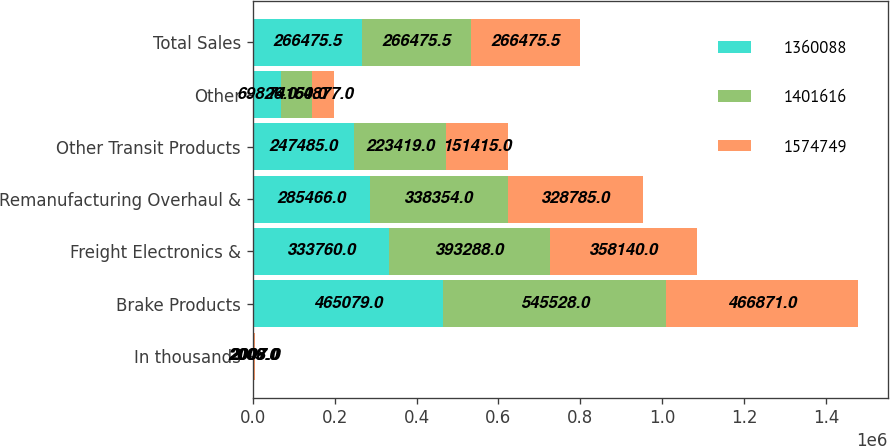Convert chart to OTSL. <chart><loc_0><loc_0><loc_500><loc_500><stacked_bar_chart><ecel><fcel>In thousands<fcel>Brake Products<fcel>Freight Electronics &<fcel>Remanufacturing Overhaul &<fcel>Other Transit Products<fcel>Other<fcel>Total Sales<nl><fcel>1.36009e+06<fcel>2009<fcel>465079<fcel>333760<fcel>285466<fcel>247485<fcel>69826<fcel>266476<nl><fcel>1.40162e+06<fcel>2008<fcel>545528<fcel>393288<fcel>338354<fcel>223419<fcel>74160<fcel>266476<nl><fcel>1.57475e+06<fcel>2007<fcel>466871<fcel>358140<fcel>328785<fcel>151415<fcel>54877<fcel>266476<nl></chart> 